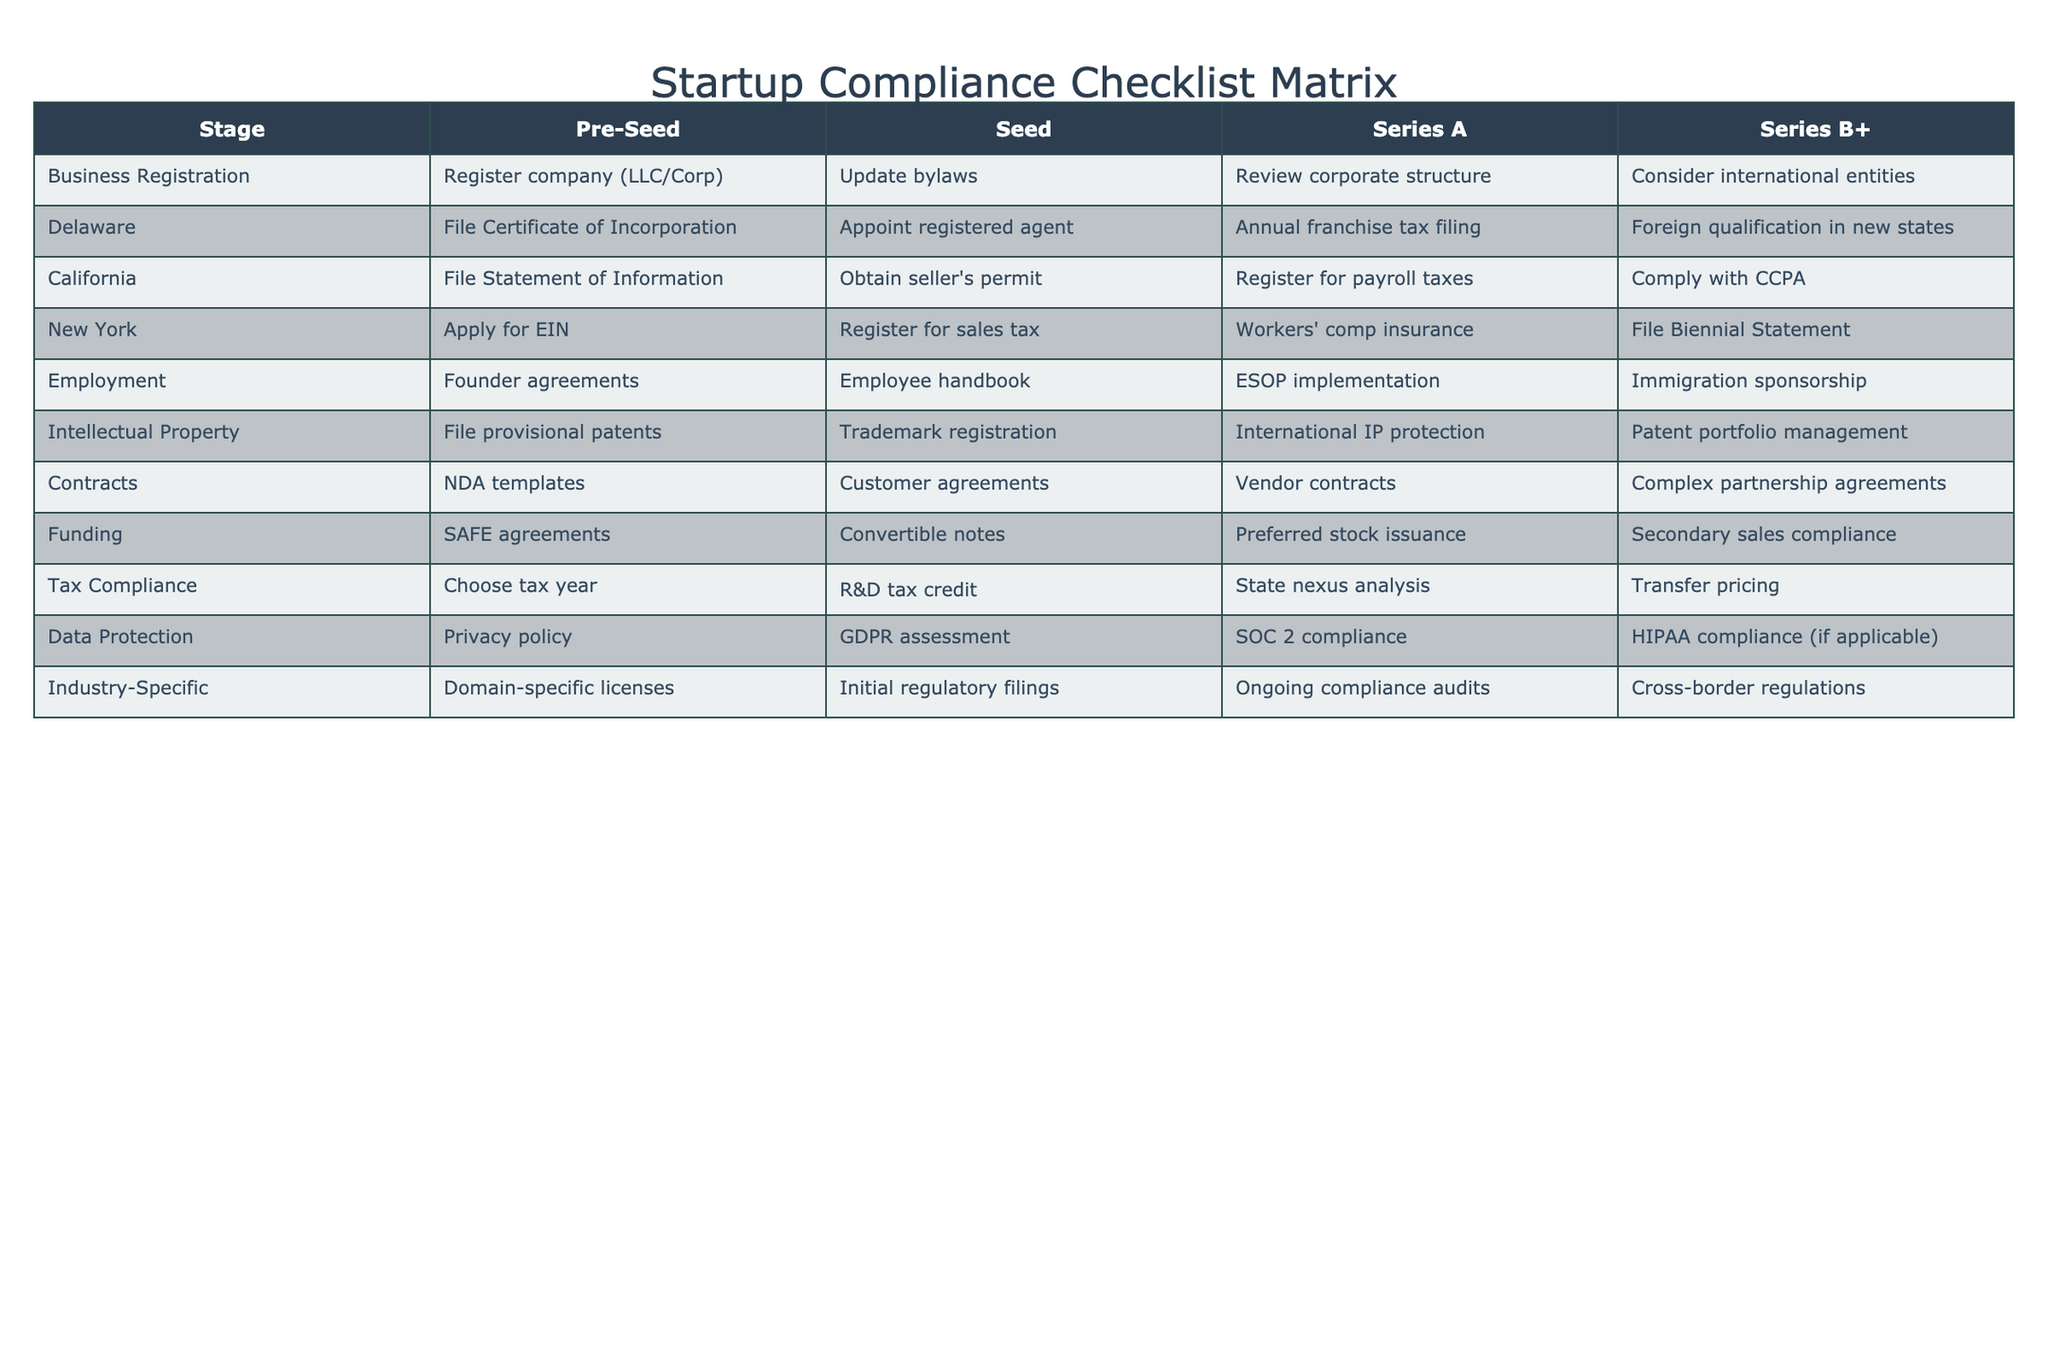What are the compliance steps required at the Seed stage in California? At the Seed stage, the compliance steps required in California include obtaining a seller's permit and registering for payroll taxes.
Answer: Obtaining a seller's permit and registering for payroll taxes Is there a requirement for international entities in Series B+? Yes, in Series B+, organizations are encouraged to consider foreign qualification in new states if they are expanding internationally.
Answer: Yes What are the key employment compliance steps across all stages? The key employment compliance steps across all stages include founder agreements at Pre-Seed, employee handbook at Seed, ESOP implementation at Series A, and immigration sponsorship at Series B+.
Answer: Founder agreements, employee handbook, ESOP implementation, immigration sponsorship Do New York companies need to file a Biennial Statement during Series A? No, filing a Biennial Statement is a requirement only at the Series B+ stage.
Answer: No What compliance steps are required for Intellectual Property in Series A? In Series A, the compliance step required for Intellectual Property is international IP protection.
Answer: International IP protection Does the Pre-Seed stage require an EIN in California? No, applying for an EIN is required in New York at the Pre-Seed stage, not California.
Answer: No Which stage requires SOC 2 compliance? SOC 2 compliance is required in the Series A stage for data protection.
Answer: Series A What is the difference in contract requirements between Seed and Series B+? The Seed stage requires NDA templates and customer agreements, while the Series B+ stage requires complex partnership agreements.
Answer: NDA templates and customer agreements vs. complex partnership agreements How many tax compliance steps are necessary by the Series B+ stage? By the Series B+ stage, there are four tax compliance steps: choose tax year, R&D tax credit, state nexus analysis, and transfer pricing.
Answer: Four tax compliance steps Is there an industry-specific requirement for the Pre-Seed stage? Yes, at the Pre-Seed stage, there is a requirement for domain-specific licenses.
Answer: Yes 